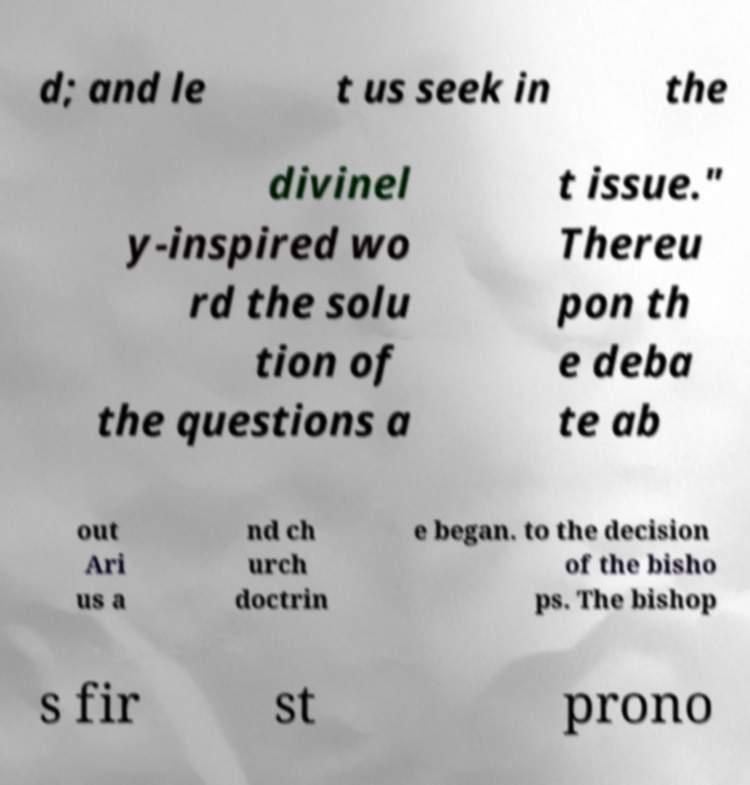For documentation purposes, I need the text within this image transcribed. Could you provide that? d; and le t us seek in the divinel y-inspired wo rd the solu tion of the questions a t issue." Thereu pon th e deba te ab out Ari us a nd ch urch doctrin e began. to the decision of the bisho ps. The bishop s fir st prono 